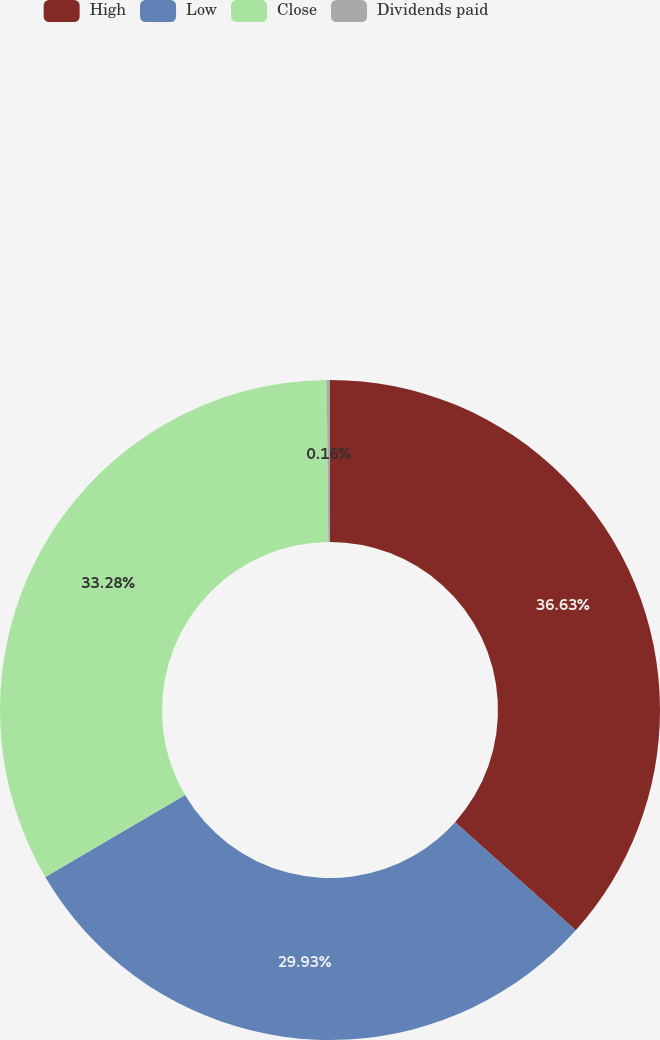Convert chart. <chart><loc_0><loc_0><loc_500><loc_500><pie_chart><fcel>High<fcel>Low<fcel>Close<fcel>Dividends paid<nl><fcel>36.63%<fcel>29.93%<fcel>33.28%<fcel>0.16%<nl></chart> 